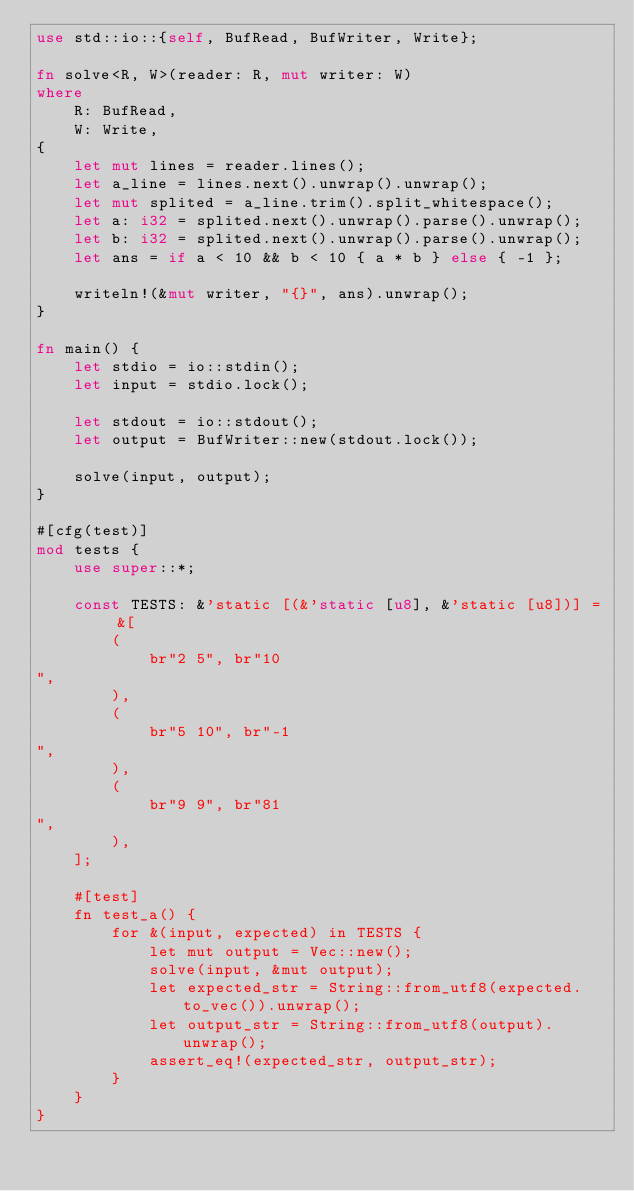<code> <loc_0><loc_0><loc_500><loc_500><_Rust_>use std::io::{self, BufRead, BufWriter, Write};

fn solve<R, W>(reader: R, mut writer: W)
where
    R: BufRead,
    W: Write,
{
    let mut lines = reader.lines();
    let a_line = lines.next().unwrap().unwrap();
    let mut splited = a_line.trim().split_whitespace();
    let a: i32 = splited.next().unwrap().parse().unwrap();
    let b: i32 = splited.next().unwrap().parse().unwrap();
    let ans = if a < 10 && b < 10 { a * b } else { -1 };

    writeln!(&mut writer, "{}", ans).unwrap();
}

fn main() {
    let stdio = io::stdin();
    let input = stdio.lock();

    let stdout = io::stdout();
    let output = BufWriter::new(stdout.lock());

    solve(input, output);
}

#[cfg(test)]
mod tests {
    use super::*;

    const TESTS: &'static [(&'static [u8], &'static [u8])] = &[
        (
            br"2 5", br"10
",
        ),
        (
            br"5 10", br"-1
",
        ),
        (
            br"9 9", br"81
",
        ),
    ];

    #[test]
    fn test_a() {
        for &(input, expected) in TESTS {
            let mut output = Vec::new();
            solve(input, &mut output);
            let expected_str = String::from_utf8(expected.to_vec()).unwrap();
            let output_str = String::from_utf8(output).unwrap();
            assert_eq!(expected_str, output_str);
        }
    }
}
</code> 